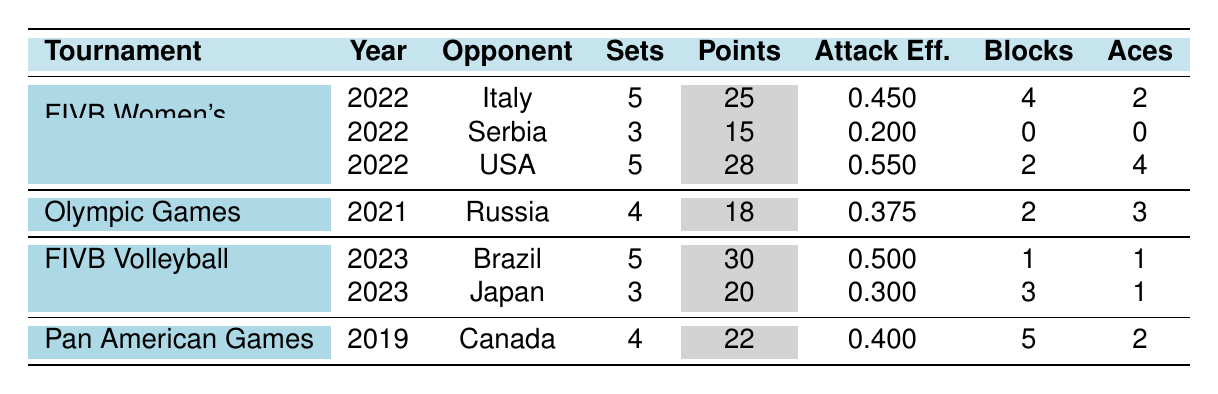What was Dani Drews' highest points scored in a match? In the table, the highest points scored by Dani Drews is 30 points in the match against Brazil during the FIVB Volleyball Nations League in 2023.
Answer: 30 points Which tournament did Dani Drews score the least number of points? By reviewing the points scored per match, the least points scored was 15 against Serbia in the FIVB Women's World Championship in 2022.
Answer: 15 points What is the average attack efficiency across all matches displayed? To calculate the average attack efficiency, sum up the efficiencies: 0.450 + 0.375 + 0.500 + 0.200 + 0.400 + 0.300 + 0.550 = 2.775. There are 7 matches, so the average is 2.775 / 7 = approximately 0.396.
Answer: Approximately 0.396 Did Dani Drews have any matches where she scored no blocks? Yes, in the match against Serbia in the FIVB Women's World Championship 2022, Dani Drews scored 0 blocks.
Answer: Yes How many total sets did Dani Drews play in the international competitions listed? To find the total sets played, sum the sets from each match: 5 + 4 + 5 + 3 + 4 + 3 + 5 = 29.
Answer: 29 sets What was the total number of serves aces scored by Dani Drews across all matches? Adding the serves aces: 2 + 3 + 1 + 0 + 2 + 1 + 4 = 13 serves aces total.
Answer: 13 aces In how many matches did Dani Drews have an attack efficiency greater than 0.4? The matches with efficiencies above 0.4 are: against Italy (0.450), Brazil (0.500), USA (0.550), and Canada (0.400) totaling 4 matches.
Answer: 4 matches Which opponent did Dani Drews face the most in terms of sets played? Dani Drews faced Italy and USA, both in matches with 5 sets played. Thus, they are tied for the most sets played.
Answer: Italy and USA What percentage of Dani Drews' matches resulted in 5 sets played? Dani Drews played a total of 7 matches; 3 matches resulted in 5 sets. Therefore, the percentage is (3/7) * 100 = approximately 42.86%.
Answer: Approximately 42.86% Which year did Dani Drews play the most matches based on the table? In the table, the year with the most matches is 2022, consisting of 3 matches listed.
Answer: 2022 